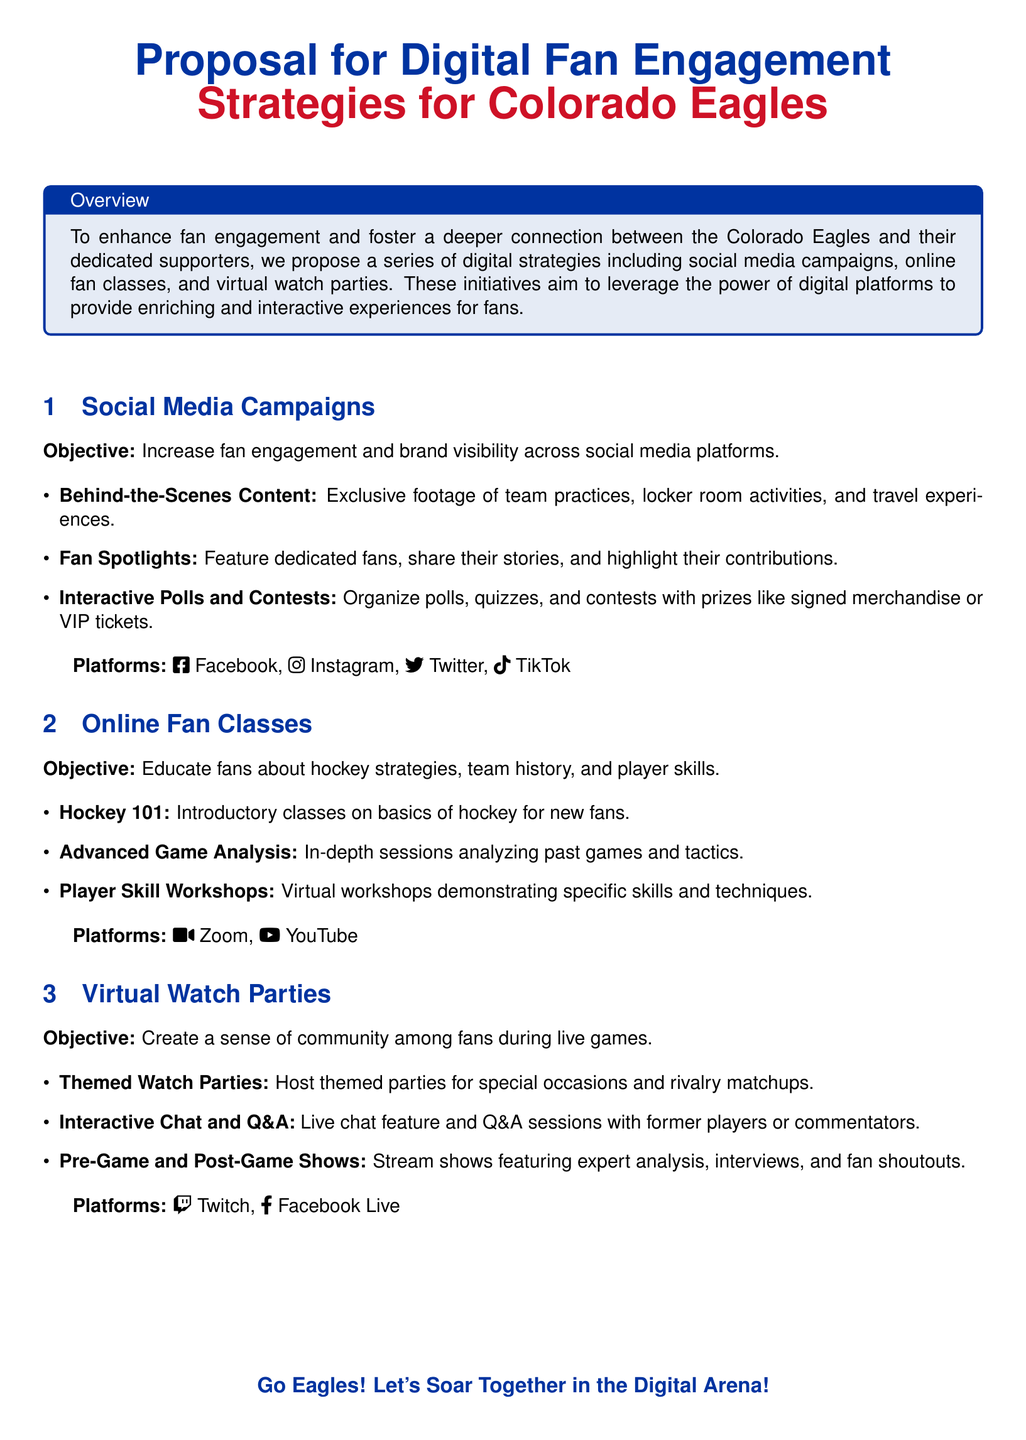What is the proposal focused on? The proposal is focused on enhancing fan engagement and fostering a deeper connection between the Colorado Eagles and their supporters.
Answer: Digital fan engagement strategies What is one of the objectives of social media campaigns? The objectives of social media campaigns include increasing fan engagement and brand visibility.
Answer: Increase fan engagement What type of content will be featured in fan spotlights? Fan spotlights will feature dedicated fans, sharing their stories and highlighting their contributions.
Answer: Dedicated fans' stories Which platform is mentioned for virtual workshops? The document mentions Zoom as a platform for online fan classes, particularly workshops.
Answer: Zoom What are virtual watch parties meant to create? Virtual watch parties aim to create a sense of community among fans during live games.
Answer: Sense of community What type of class is Hockey 101? Hockey 101 is an introductory class on the basics of hockey for new fans.
Answer: Introductory class Which social media platform is used for interactive polls and contests? Interactive polls and contests are organized on platforms like Facebook, Instagram, Twitter, and TikTok.
Answer: Facebook, Instagram, Twitter, TikTok What is streamed during the pre-game and post-game shows? The pre-game and post-game shows feature expert analysis, interviews, and fan shoutouts.
Answer: Expert analysis and interviews 